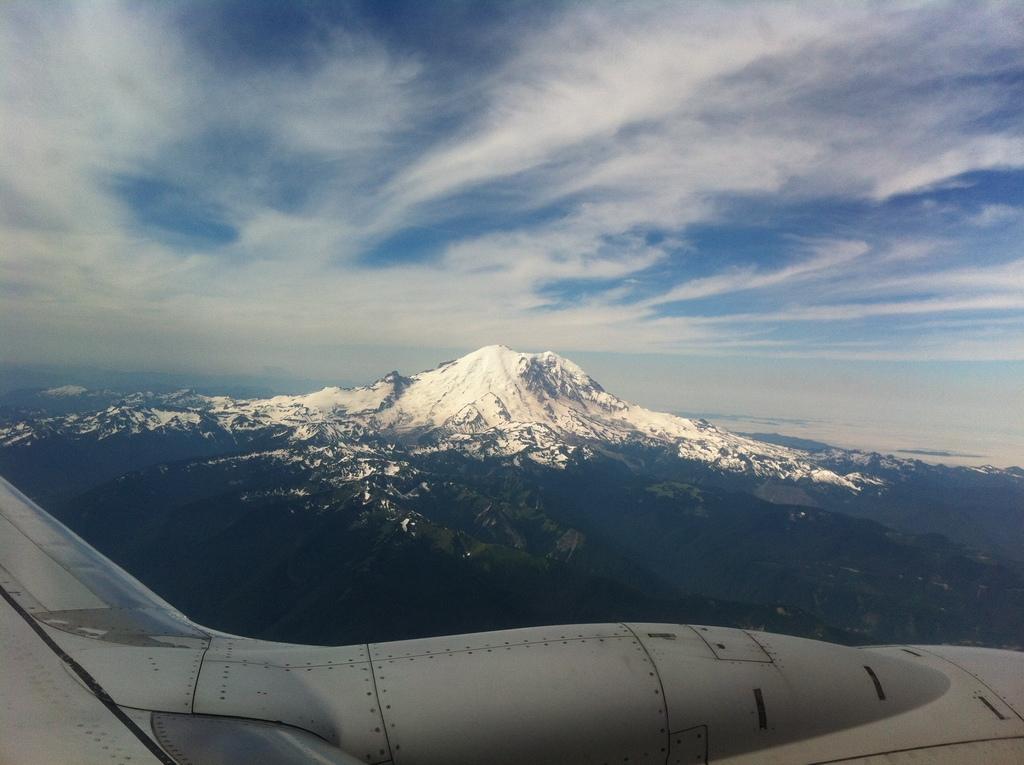Could you give a brief overview of what you see in this image? In the image we can see there is an upper part of an aeroplane and behind there is a mountain which is covered with snow. There is a clear sky on the top. 